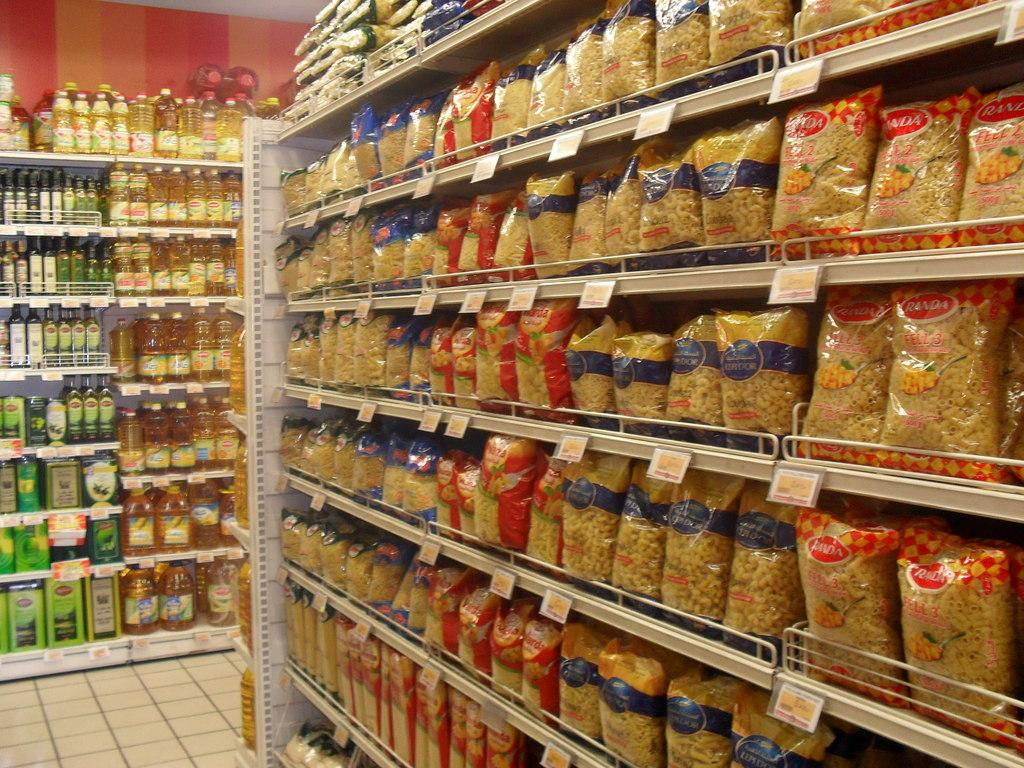What type of establishment is shown in the image? There is a store in the image. What can be found on the racks in the store? The store has racks full of bottles. What else is on display in the store? The store has packets on display. How can customers determine the price of items in the store? There are price tags visible in the image. What are the two main surfaces visible in the store? There is a wall and a floor visible in the image. What type of car is parked in front of the store in the image? There is no car visible in the image; it only shows the interior of the store. 